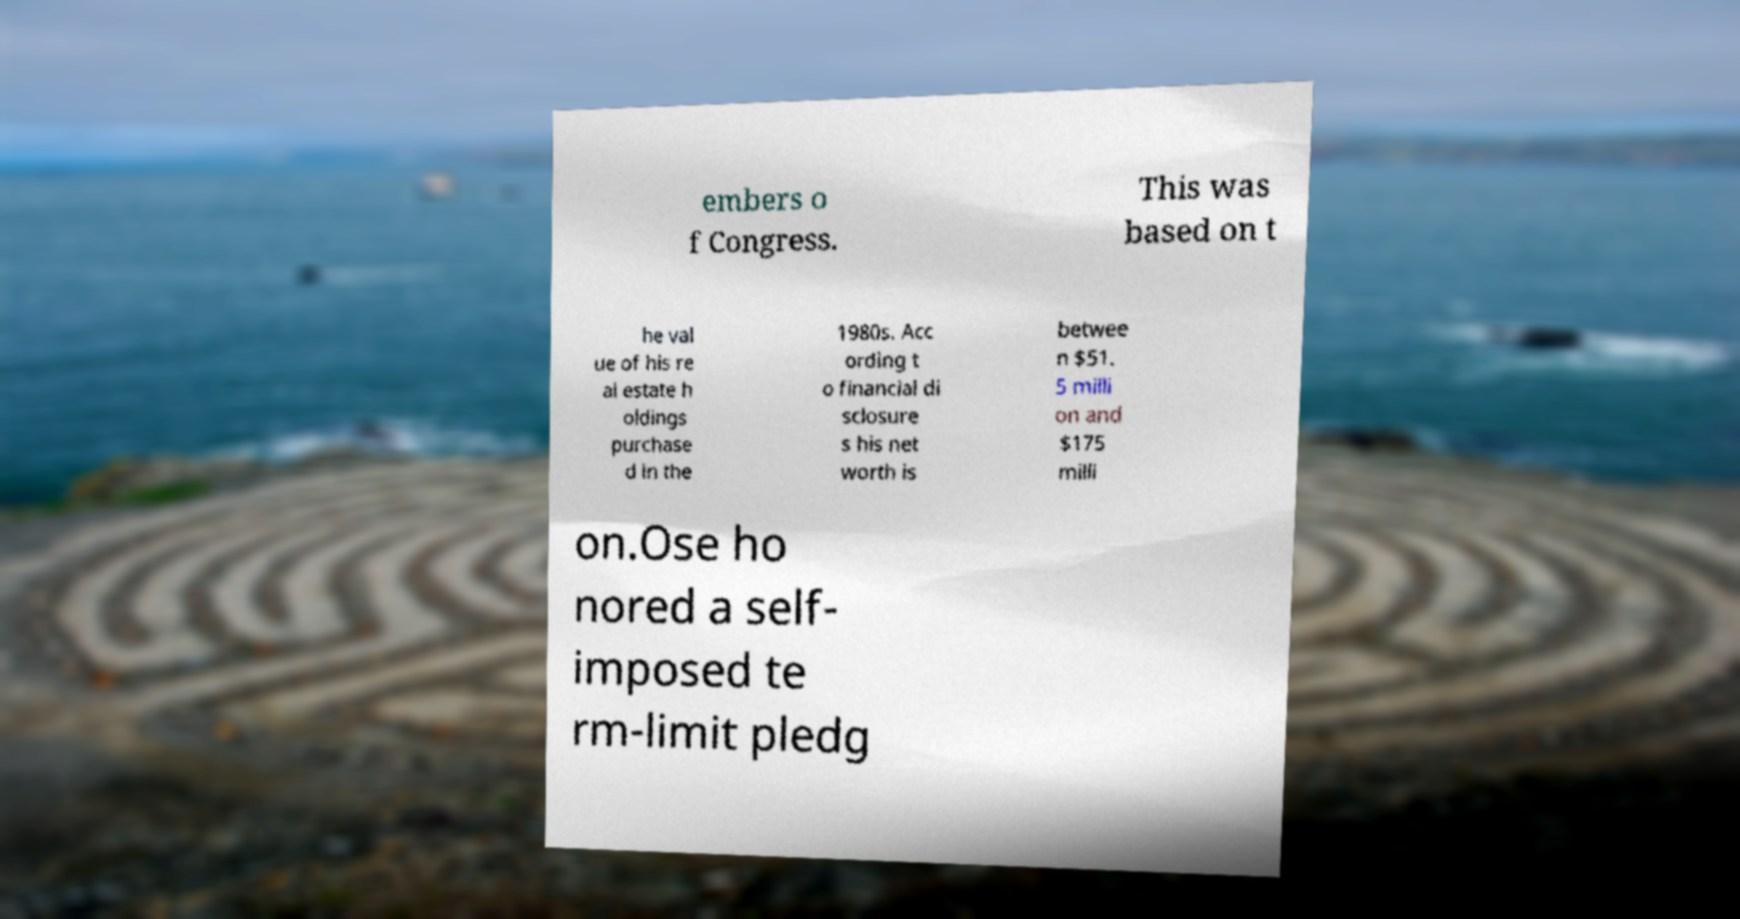There's text embedded in this image that I need extracted. Can you transcribe it verbatim? embers o f Congress. This was based on t he val ue of his re al estate h oldings purchase d in the 1980s. Acc ording t o financial di sclosure s his net worth is betwee n $51. 5 milli on and $175 milli on.Ose ho nored a self- imposed te rm-limit pledg 